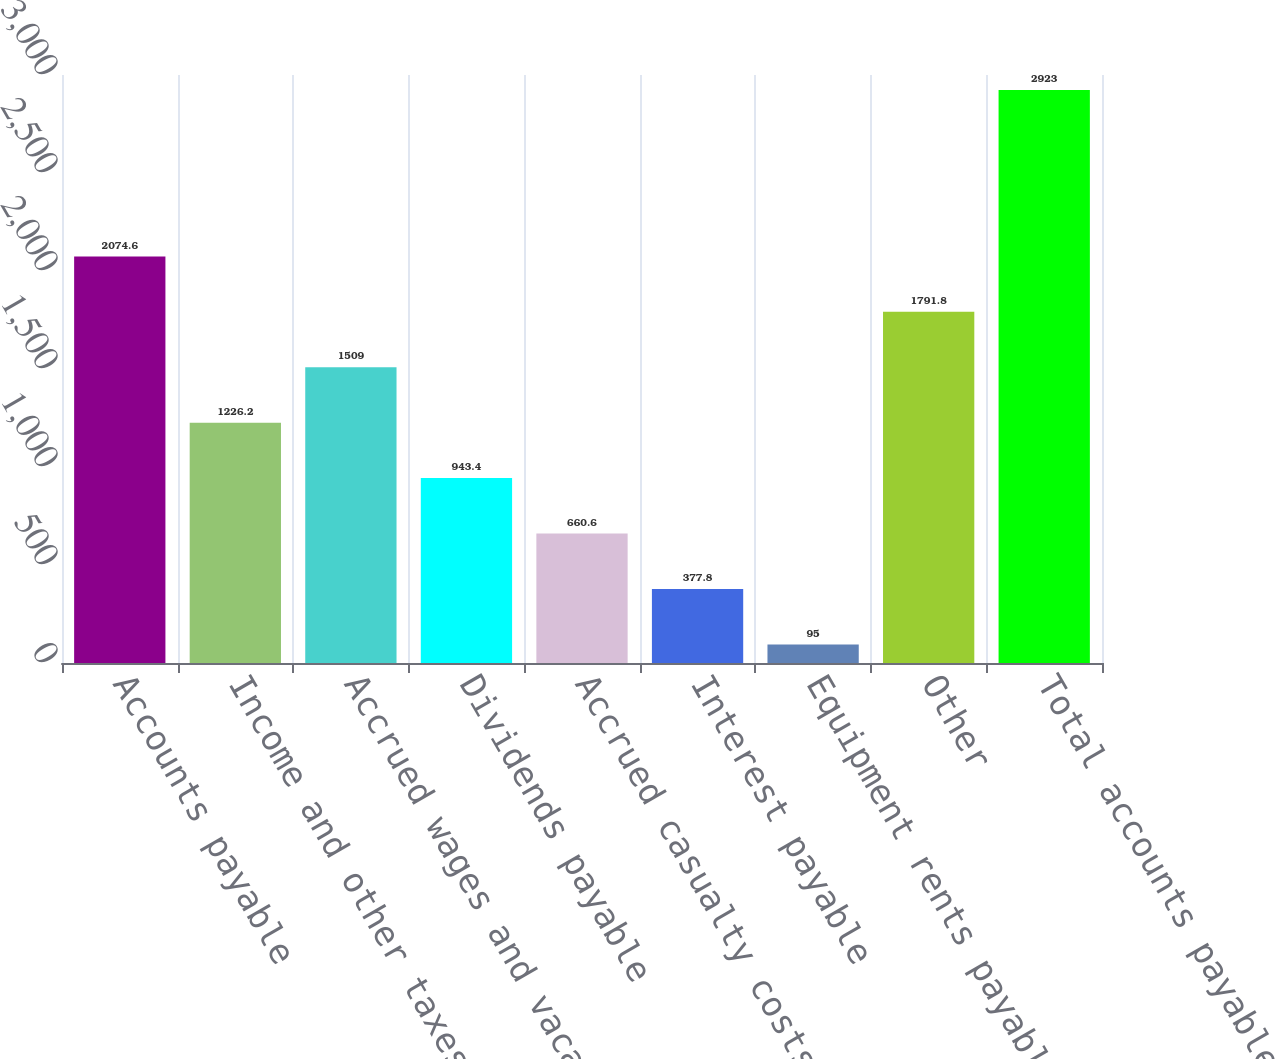Convert chart to OTSL. <chart><loc_0><loc_0><loc_500><loc_500><bar_chart><fcel>Accounts payable<fcel>Income and other taxes payable<fcel>Accrued wages and vacation<fcel>Dividends payable<fcel>Accrued casualty costs<fcel>Interest payable<fcel>Equipment rents payable<fcel>Other<fcel>Total accounts payable and<nl><fcel>2074.6<fcel>1226.2<fcel>1509<fcel>943.4<fcel>660.6<fcel>377.8<fcel>95<fcel>1791.8<fcel>2923<nl></chart> 